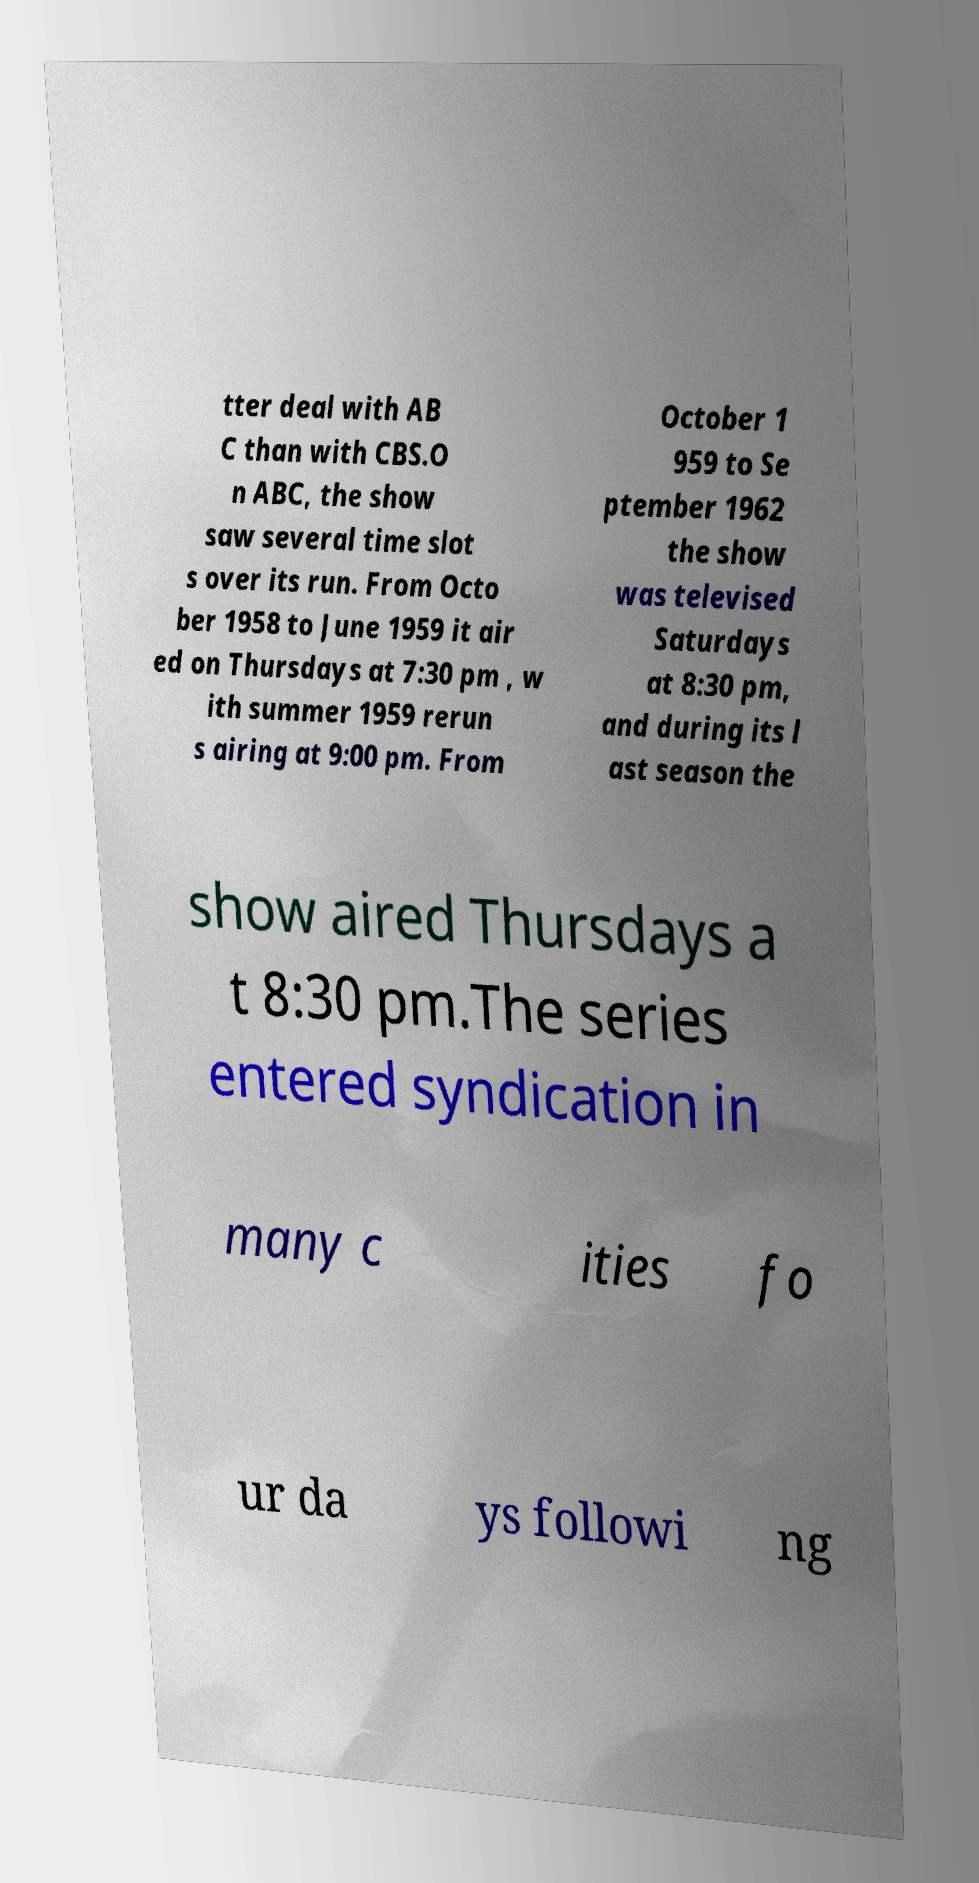Please identify and transcribe the text found in this image. tter deal with AB C than with CBS.O n ABC, the show saw several time slot s over its run. From Octo ber 1958 to June 1959 it air ed on Thursdays at 7:30 pm , w ith summer 1959 rerun s airing at 9:00 pm. From October 1 959 to Se ptember 1962 the show was televised Saturdays at 8:30 pm, and during its l ast season the show aired Thursdays a t 8:30 pm.The series entered syndication in many c ities fo ur da ys followi ng 